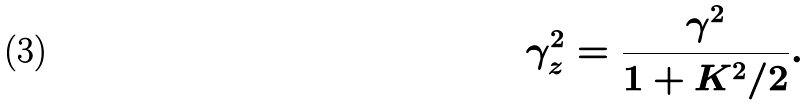<formula> <loc_0><loc_0><loc_500><loc_500>\gamma _ { z } ^ { 2 } = \frac { \gamma ^ { 2 } } { 1 + K ^ { 2 } / 2 } .</formula> 